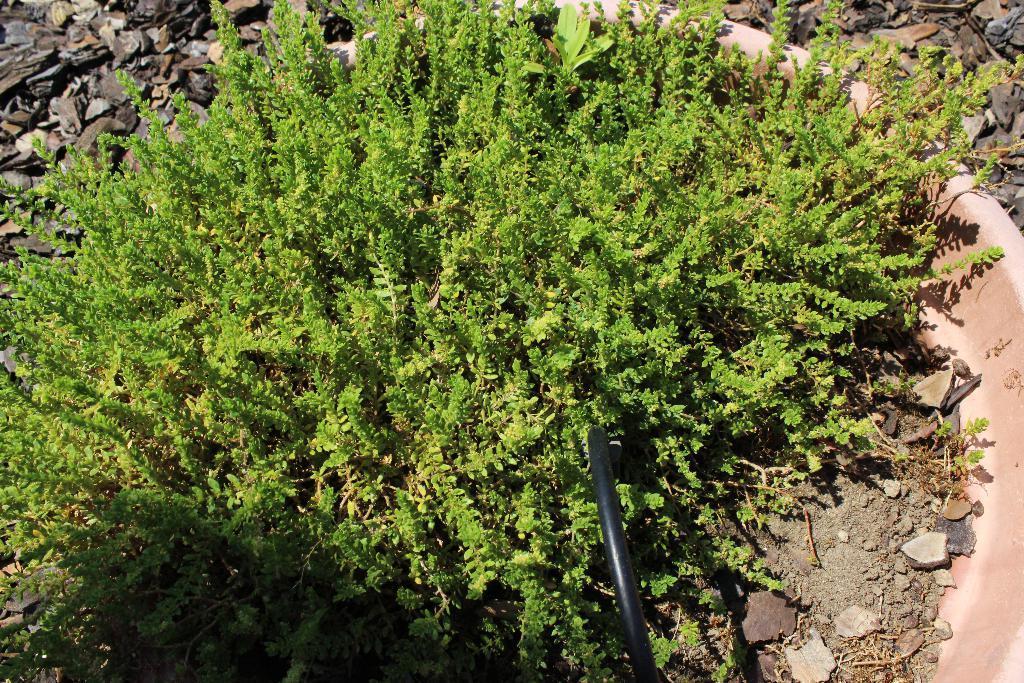In one or two sentences, can you explain what this image depicts? In this image I can see there are green plants. At the bottom there is a pipe in black color and there are stones on the right side in this image. 